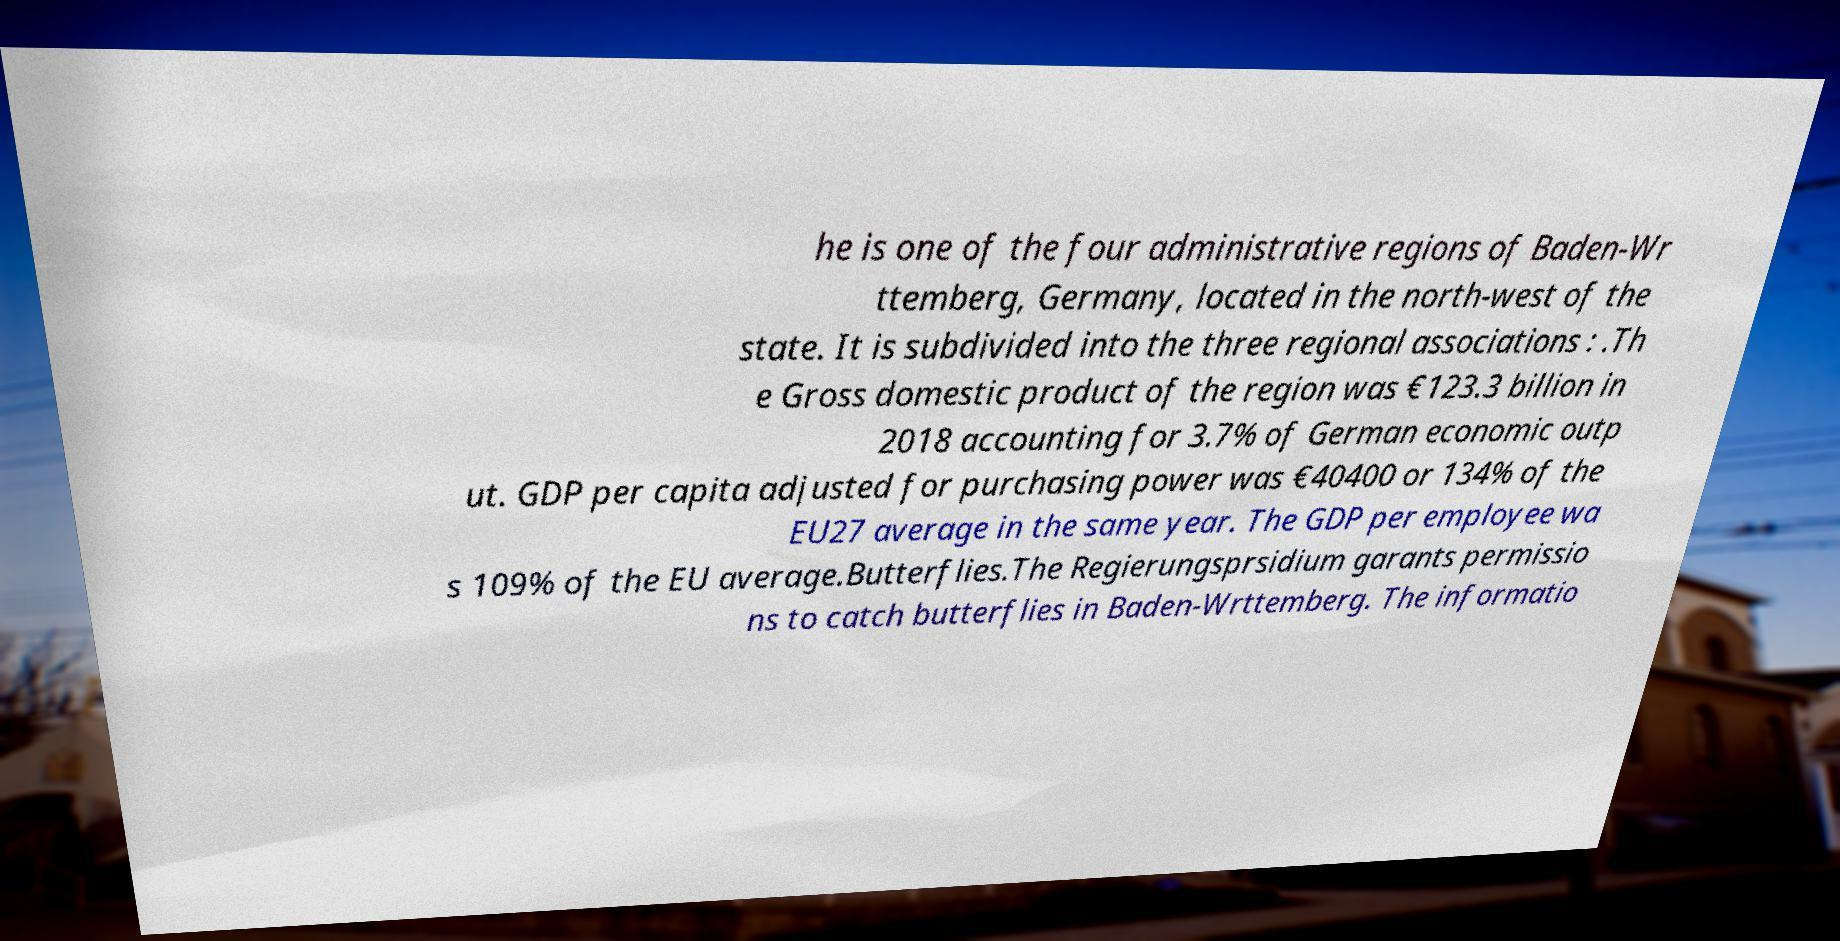Can you accurately transcribe the text from the provided image for me? he is one of the four administrative regions of Baden-Wr ttemberg, Germany, located in the north-west of the state. It is subdivided into the three regional associations : .Th e Gross domestic product of the region was €123.3 billion in 2018 accounting for 3.7% of German economic outp ut. GDP per capita adjusted for purchasing power was €40400 or 134% of the EU27 average in the same year. The GDP per employee wa s 109% of the EU average.Butterflies.The Regierungsprsidium garants permissio ns to catch butterflies in Baden-Wrttemberg. The informatio 